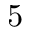Convert formula to latex. <formula><loc_0><loc_0><loc_500><loc_500>5</formula> 